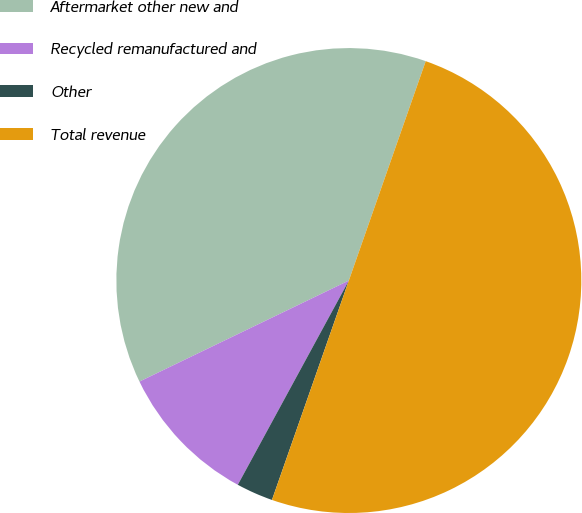Convert chart. <chart><loc_0><loc_0><loc_500><loc_500><pie_chart><fcel>Aftermarket other new and<fcel>Recycled remanufactured and<fcel>Other<fcel>Total revenue<nl><fcel>37.52%<fcel>9.92%<fcel>2.56%<fcel>50.0%<nl></chart> 